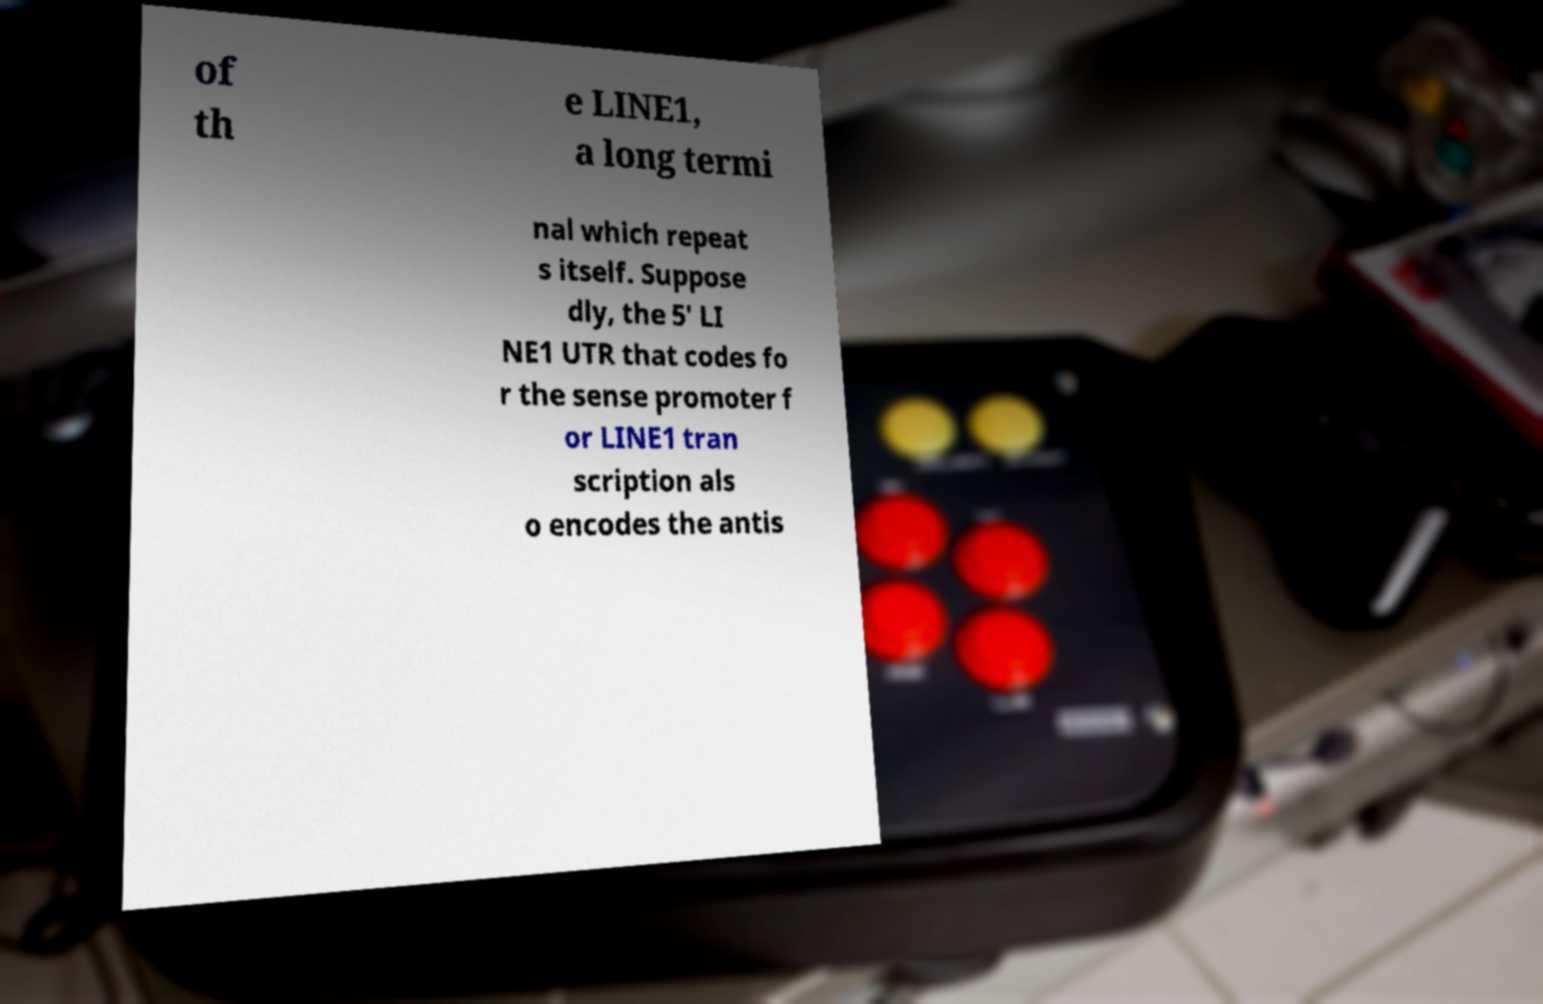I need the written content from this picture converted into text. Can you do that? of th e LINE1, a long termi nal which repeat s itself. Suppose dly, the 5′ LI NE1 UTR that codes fo r the sense promoter f or LINE1 tran scription als o encodes the antis 